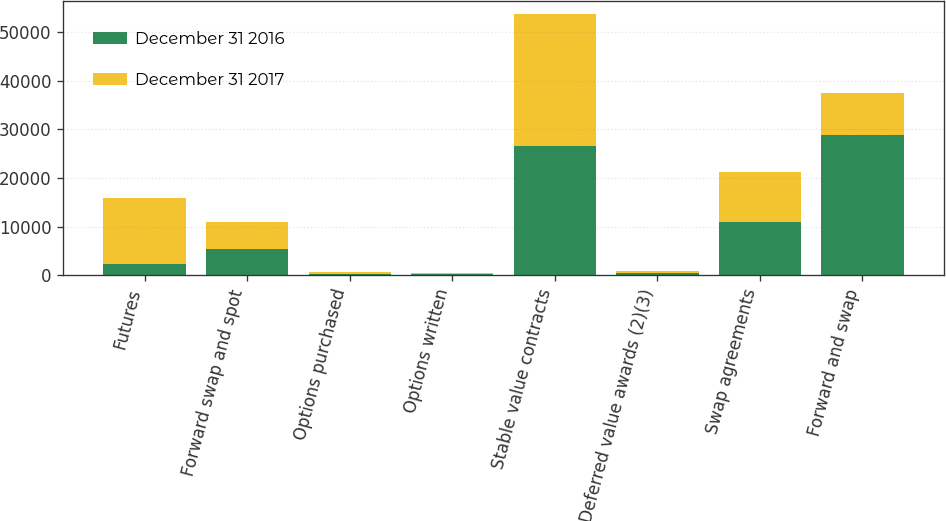Convert chart to OTSL. <chart><loc_0><loc_0><loc_500><loc_500><stacked_bar_chart><ecel><fcel>Futures<fcel>Forward swap and spot<fcel>Options purchased<fcel>Options written<fcel>Stable value contracts<fcel>Deferred value awards (2)(3)<fcel>Swap agreements<fcel>Forward and swap<nl><fcel>December 31 2016<fcel>2392<fcel>5478<fcel>350<fcel>302<fcel>26653<fcel>473<fcel>11047<fcel>28913<nl><fcel>December 31 2017<fcel>13455<fcel>5478<fcel>337<fcel>202<fcel>27182<fcel>409<fcel>10169<fcel>8564<nl></chart> 